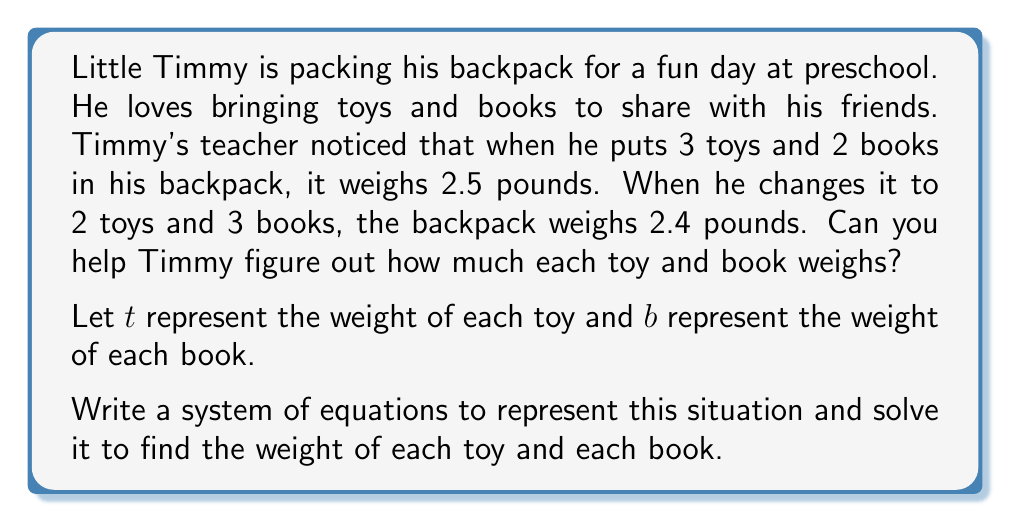Can you answer this question? Let's approach this step-by-step:

1) First, we'll set up our system of equations based on the information given:

   Equation 1: $3t + 2b = 2.5$ (3 toys and 2 books weigh 2.5 pounds)
   Equation 2: $2t + 3b = 2.4$ (2 toys and 3 books weigh 2.4 pounds)

2) Now, we'll solve this system using the elimination method:

3) Multiply the second equation by 3 and the first equation by 2:

   Equation 1: $6t + 4b = 5$
   Equation 2: $6t + 9b = 7.2$

4) Subtract the first equation from the second:

   $5b = 2.2$

5) Divide both sides by 5 to solve for $b$:

   $b = 0.44$

6) Now that we know $b$, we can substitute this value into either of our original equations. Let's use the first one:

   $3t + 2(0.44) = 2.5$
   $3t + 0.88 = 2.5$
   $3t = 1.62$
   $t = 0.54$

Therefore, each toy weighs 0.54 pounds and each book weighs 0.44 pounds.
Answer: Each toy weighs 0.54 pounds and each book weighs 0.44 pounds. 